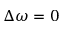<formula> <loc_0><loc_0><loc_500><loc_500>\Delta \omega = 0</formula> 